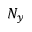Convert formula to latex. <formula><loc_0><loc_0><loc_500><loc_500>N _ { y }</formula> 